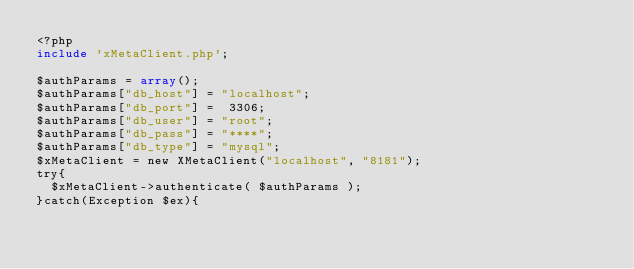Convert code to text. <code><loc_0><loc_0><loc_500><loc_500><_PHP_><?php
include 'xMetaClient.php';

$authParams = array();
$authParams["db_host"] = "localhost"; 
$authParams["db_port"] =  3306;
$authParams["db_user"] = "root";
$authParams["db_pass"] = "****";
$authParams["db_type"] = "mysql";
$xMetaClient = new XMetaClient("localhost", "8181");
try{
  $xMetaClient->authenticate( $authParams );
}catch(Exception $ex){
</code> 